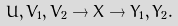Convert formula to latex. <formula><loc_0><loc_0><loc_500><loc_500>U , V _ { 1 } , V _ { 2 } \rightarrow X \rightarrow Y _ { 1 } , Y _ { 2 } .</formula> 